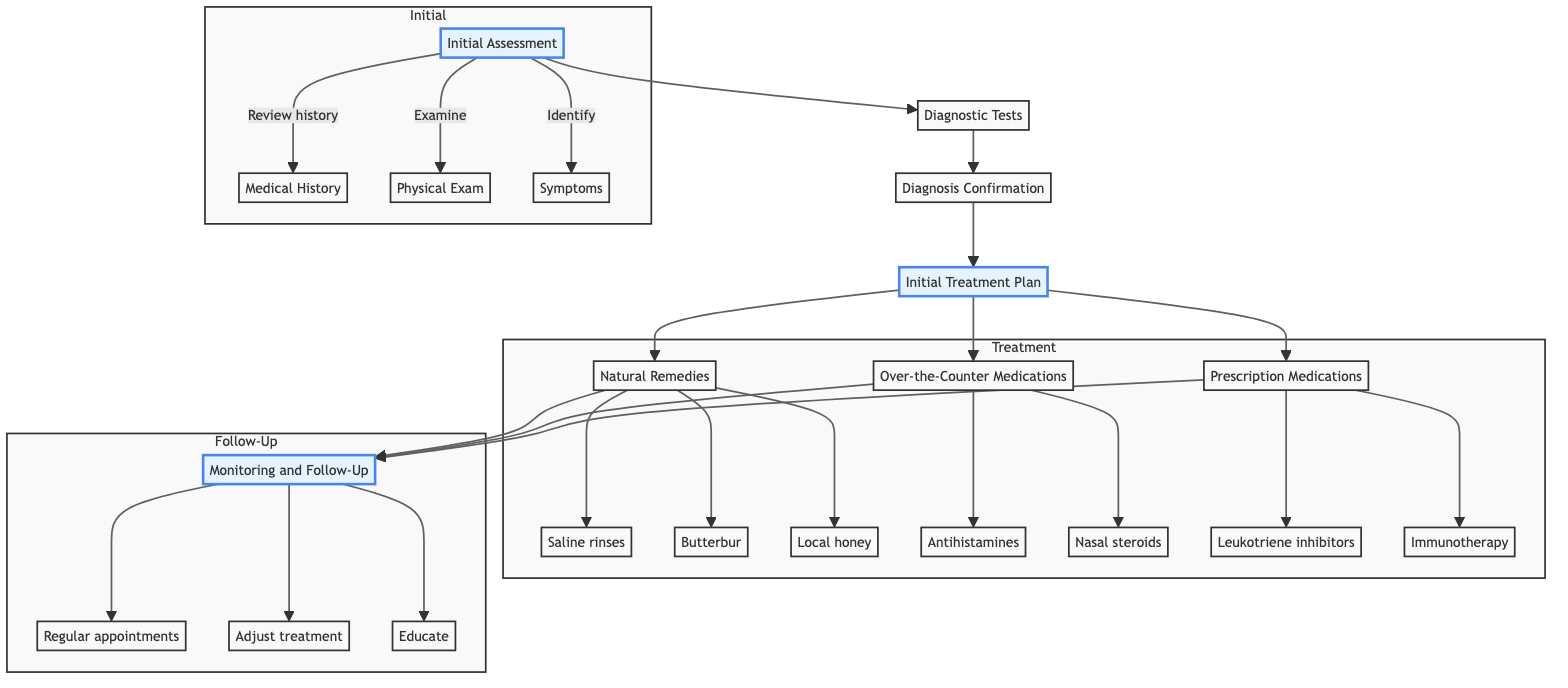What is the first step in the clinical pathway? The first step in the pathway, as indicated in the diagram, is "Initial Assessment." It is the first node that starts the flow of the diagnosis and treatment process.
Answer: Initial Assessment How many treatment options follow the initial treatment plan? After the "Initial Treatment Plan," there are three distinct treatment option paths shown: "Natural Remedies," "Over-the-Counter Medications," and "Prescription Medications." Counting these branches gives a total of three options.
Answer: 3 What is one of the actions included in the initial assessment? One of the actions listed under "Initial Assessment" is "Conduct physical examination." This is detailed as part of the specific actions that occur at this step in the diagram.
Answer: Conduct physical examination Which step involves monitoring and follow-up? The "Monitoring and Follow-Up" step is indicated towards the end of the diagram, demonstrating the ongoing care after treatment has been initiated. This step consolidates the results of previous treatments and assures patient care continuity.
Answer: Monitoring and Follow-Up Which natural remedy is suggested under the natural remedies step? In the "Natural Remedies" section, "Saline nasal rinses" is one of the specific actions highlighted for managing seasonal allergies. This suggests a method for alleviating symptoms naturally.
Answer: Saline nasal rinses What diagnostic test is primarily referenced for confirming the diagnosis? The diagram lists "Skin prick test" as one of the key diagnostic tests for confirming the diagnosis, which plays a crucial role in understanding the specific allergic triggers for the child.
Answer: Skin prick test What are two examples of over-the-counter medications mentioned? The "Over-the-Counter Medications" step contains two examples: "Antihistamines (e.g., Claritin, Zyrtec)" and "Nasal corticosteroids (e.g., Flonase, Nasonex)." These are both stated as common options available for treatment.
Answer: Antihistamines, Nasal corticosteroids How does the flowchart structure relate follow-up actions to treatment options? The flowchart shows that all treatment options, whether natural remedies, over-the-counter medications, or prescription medications, ultimately lead to "Monitoring and Follow-Up." This illustrates that monitoring is essential after any treatment is implemented.
Answer: Monitoring and Follow-Up 